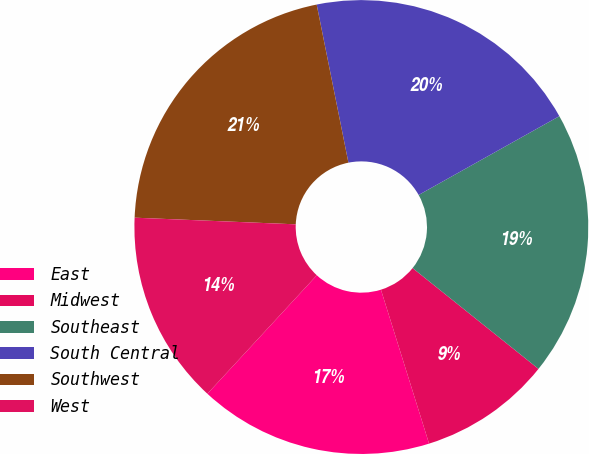<chart> <loc_0><loc_0><loc_500><loc_500><pie_chart><fcel>East<fcel>Midwest<fcel>Southeast<fcel>South Central<fcel>Southwest<fcel>West<nl><fcel>16.69%<fcel>9.43%<fcel>18.87%<fcel>20.03%<fcel>21.19%<fcel>13.79%<nl></chart> 